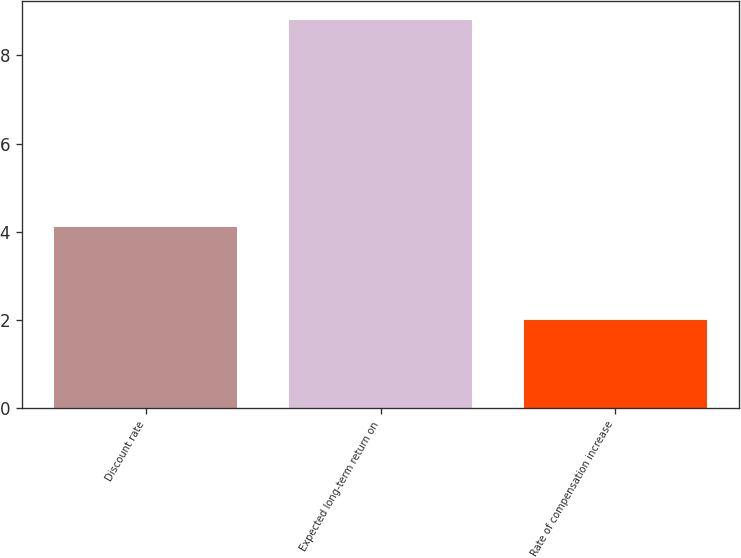Convert chart to OTSL. <chart><loc_0><loc_0><loc_500><loc_500><bar_chart><fcel>Discount rate<fcel>Expected long-term return on<fcel>Rate of compensation increase<nl><fcel>4.1<fcel>8.8<fcel>2<nl></chart> 